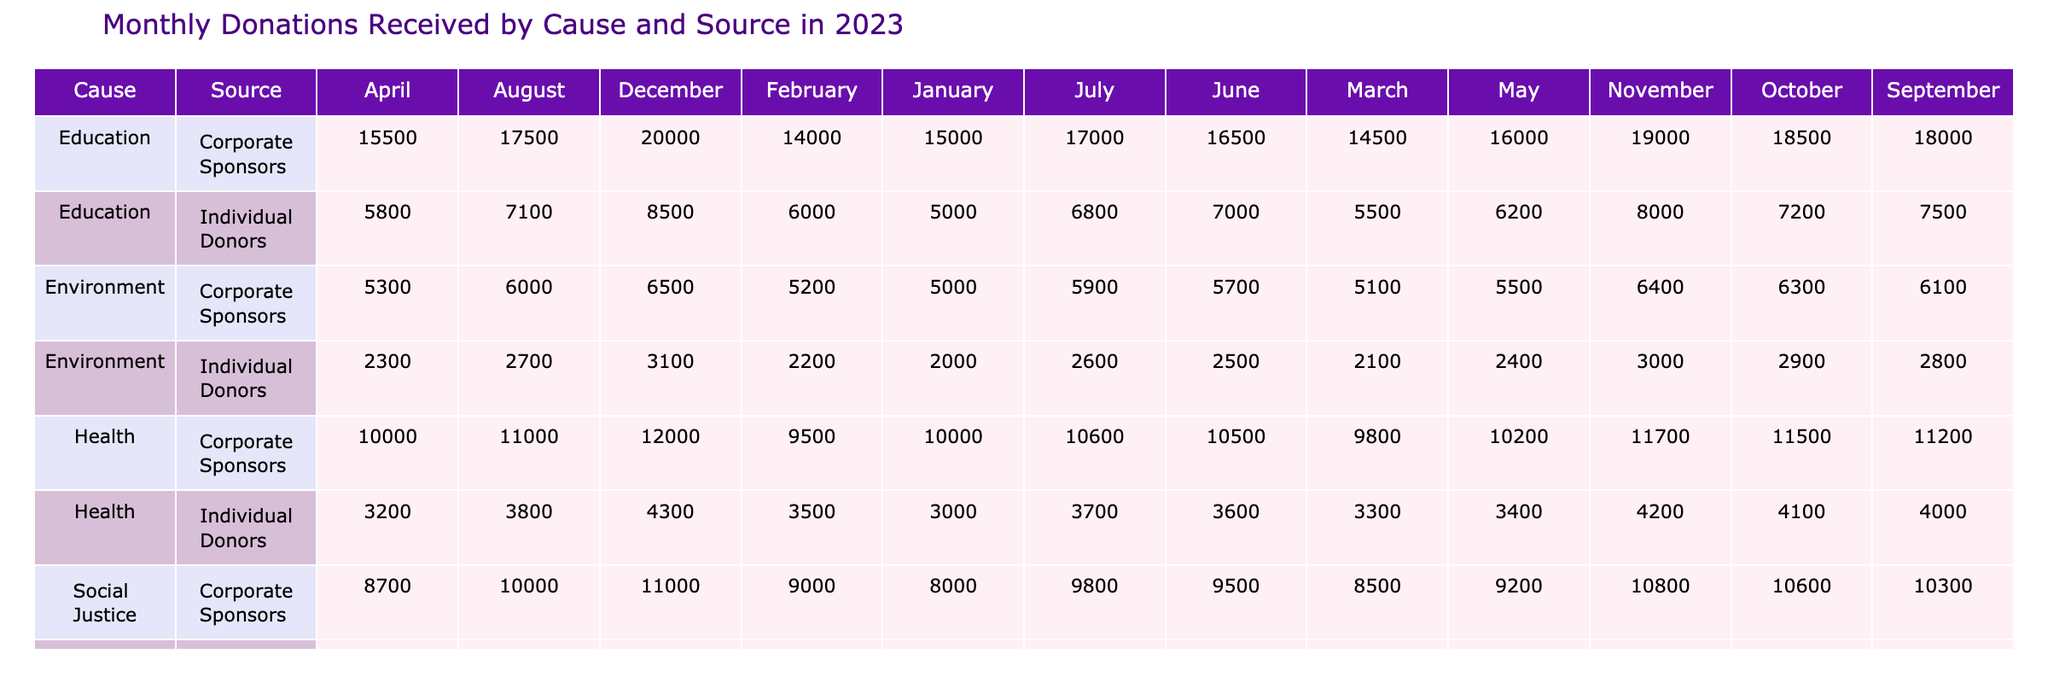What is the total amount donated to the Education cause from Corporate Sponsors in December? Looking at the row for Education and the column for December, the value is 20000, which indicates the total amount donated from Corporate Sponsors for that cause in that month.
Answer: 20000 What is the highest monthly donation recorded for Individual Donors under the Health cause? Scanning the Health cause section under Individual Donors, the monthly donations are: 3000, 3500, 3300, 3200, 3400, 3600, 3700, 3800, 4000, 4100, 4200, and 4300. The highest value in this series is 4300 in December.
Answer: 4300 Which cause received the least amount of funding from Individual Donors in July? For July, the donations from Individual Donors for each cause are: Education 6800, Health 3700, Environment 2600, and Social Justice 4650. The lowest value is 2600 for the Environment cause.
Answer: Environment Was there an increase in donations from Corporate Sponsors to the Social Justice cause from January to March? The donations from Corporate Sponsors to Social Justice in January is 8000 and for March it is 8500. The difference is 8500 - 8000 = 500, indicating an increase.
Answer: Yes What was the average monthly donation for the Environment cause in 2023? The donations for the Environment cause are: 2000, 2200, 2100, 2300, 2400, 2500, 2600, 2700, 2800, 2900, 3000, and 3100. The total is 2000+2200+2100+2300+2400+2500+2600+2700+2800+2900+3000+3100 = 32900. There are 12 months, so the average is 32900/12 = 2741.67.
Answer: 2741.67 How much more did Corporate Sponsors donate to Education in November compared to Health in the same month? Education received 19000 in November from Corporate Sponsors, and Health received 11700 in the same month. The difference is 19000 - 11700 = 7300, indicating that Education received 7300 more from Corporate Sponsors in November than Health.
Answer: 7300 